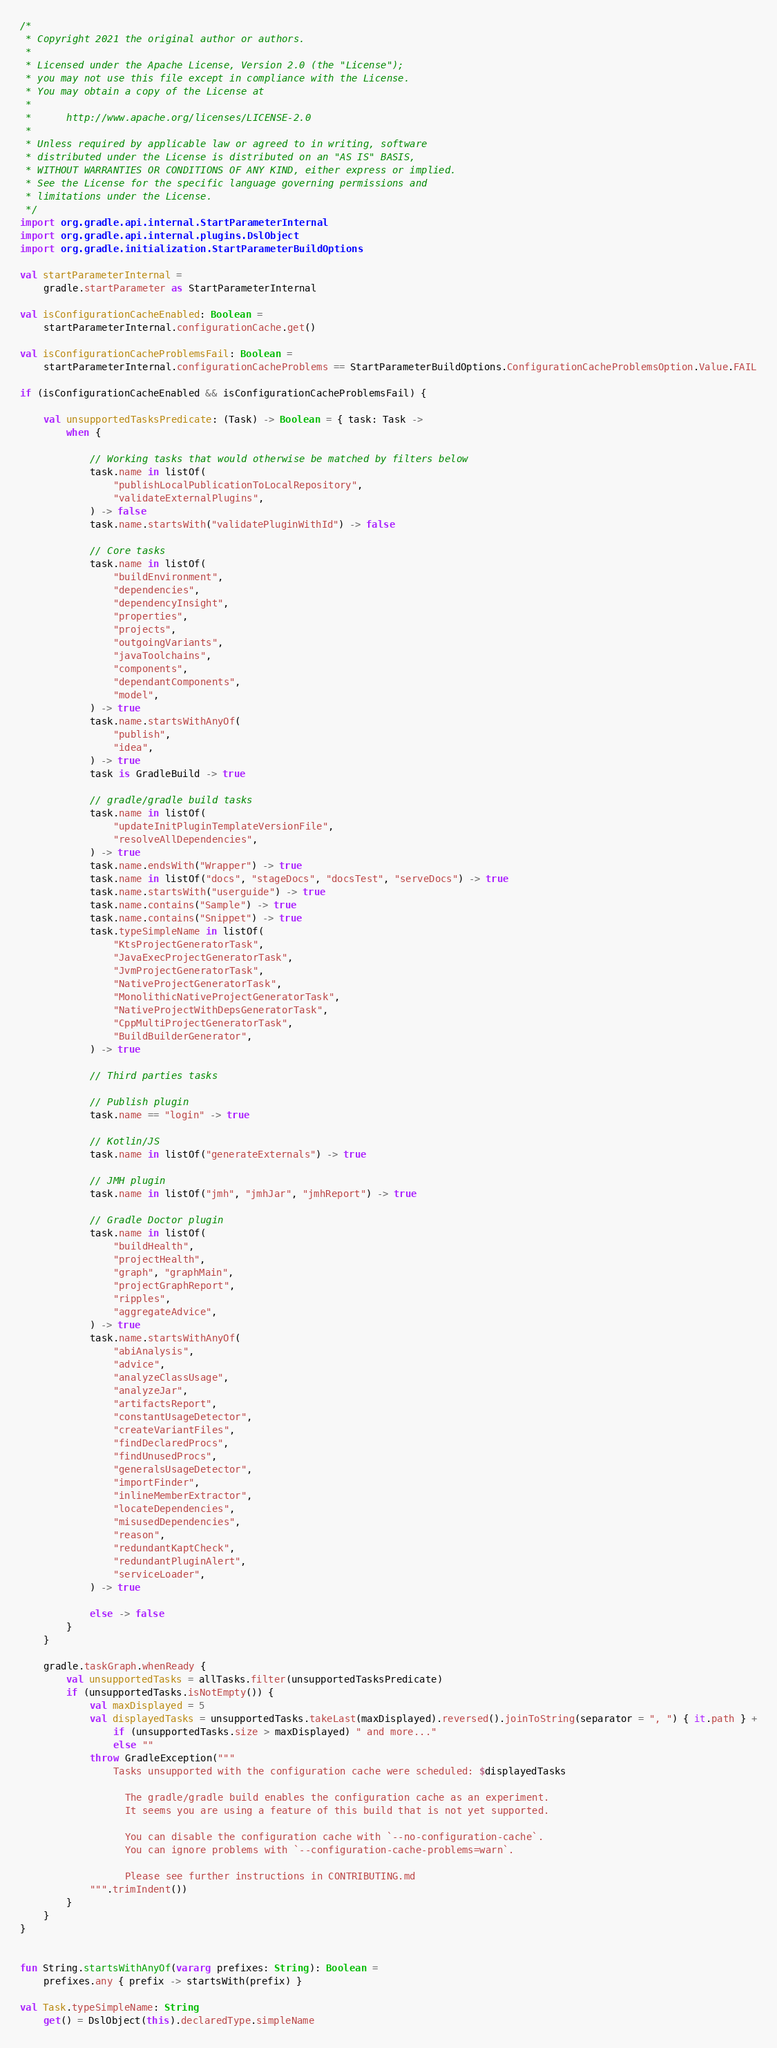<code> <loc_0><loc_0><loc_500><loc_500><_Kotlin_>/*
 * Copyright 2021 the original author or authors.
 *
 * Licensed under the Apache License, Version 2.0 (the "License");
 * you may not use this file except in compliance with the License.
 * You may obtain a copy of the License at
 *
 *      http://www.apache.org/licenses/LICENSE-2.0
 *
 * Unless required by applicable law or agreed to in writing, software
 * distributed under the License is distributed on an "AS IS" BASIS,
 * WITHOUT WARRANTIES OR CONDITIONS OF ANY KIND, either express or implied.
 * See the License for the specific language governing permissions and
 * limitations under the License.
 */
import org.gradle.api.internal.StartParameterInternal
import org.gradle.api.internal.plugins.DslObject
import org.gradle.initialization.StartParameterBuildOptions

val startParameterInternal =
    gradle.startParameter as StartParameterInternal

val isConfigurationCacheEnabled: Boolean =
    startParameterInternal.configurationCache.get()

val isConfigurationCacheProblemsFail: Boolean =
    startParameterInternal.configurationCacheProblems == StartParameterBuildOptions.ConfigurationCacheProblemsOption.Value.FAIL

if (isConfigurationCacheEnabled && isConfigurationCacheProblemsFail) {

    val unsupportedTasksPredicate: (Task) -> Boolean = { task: Task ->
        when {

            // Working tasks that would otherwise be matched by filters below
            task.name in listOf(
                "publishLocalPublicationToLocalRepository",
                "validateExternalPlugins",
            ) -> false
            task.name.startsWith("validatePluginWithId") -> false

            // Core tasks
            task.name in listOf(
                "buildEnvironment",
                "dependencies",
                "dependencyInsight",
                "properties",
                "projects",
                "outgoingVariants",
                "javaToolchains",
                "components",
                "dependantComponents",
                "model",
            ) -> true
            task.name.startsWithAnyOf(
                "publish",
                "idea",
            ) -> true
            task is GradleBuild -> true

            // gradle/gradle build tasks
            task.name in listOf(
                "updateInitPluginTemplateVersionFile",
                "resolveAllDependencies",
            ) -> true
            task.name.endsWith("Wrapper") -> true
            task.name in listOf("docs", "stageDocs", "docsTest", "serveDocs") -> true
            task.name.startsWith("userguide") -> true
            task.name.contains("Sample") -> true
            task.name.contains("Snippet") -> true
            task.typeSimpleName in listOf(
                "KtsProjectGeneratorTask",
                "JavaExecProjectGeneratorTask",
                "JvmProjectGeneratorTask",
                "NativeProjectGeneratorTask",
                "MonolithicNativeProjectGeneratorTask",
                "NativeProjectWithDepsGeneratorTask",
                "CppMultiProjectGeneratorTask",
                "BuildBuilderGenerator",
            ) -> true

            // Third parties tasks

            // Publish plugin
            task.name == "login" -> true

            // Kotlin/JS
            task.name in listOf("generateExternals") -> true

            // JMH plugin
            task.name in listOf("jmh", "jmhJar", "jmhReport") -> true

            // Gradle Doctor plugin
            task.name in listOf(
                "buildHealth",
                "projectHealth",
                "graph", "graphMain",
                "projectGraphReport",
                "ripples",
                "aggregateAdvice",
            ) -> true
            task.name.startsWithAnyOf(
                "abiAnalysis",
                "advice",
                "analyzeClassUsage",
                "analyzeJar",
                "artifactsReport",
                "constantUsageDetector",
                "createVariantFiles",
                "findDeclaredProcs",
                "findUnusedProcs",
                "generalsUsageDetector",
                "importFinder",
                "inlineMemberExtractor",
                "locateDependencies",
                "misusedDependencies",
                "reason",
                "redundantKaptCheck",
                "redundantPluginAlert",
                "serviceLoader",
            ) -> true

            else -> false
        }
    }

    gradle.taskGraph.whenReady {
        val unsupportedTasks = allTasks.filter(unsupportedTasksPredicate)
        if (unsupportedTasks.isNotEmpty()) {
            val maxDisplayed = 5
            val displayedTasks = unsupportedTasks.takeLast(maxDisplayed).reversed().joinToString(separator = ", ") { it.path } +
                if (unsupportedTasks.size > maxDisplayed) " and more..."
                else ""
            throw GradleException("""
                Tasks unsupported with the configuration cache were scheduled: $displayedTasks

                  The gradle/gradle build enables the configuration cache as an experiment.
                  It seems you are using a feature of this build that is not yet supported.

                  You can disable the configuration cache with `--no-configuration-cache`.
                  You can ignore problems with `--configuration-cache-problems=warn`.

                  Please see further instructions in CONTRIBUTING.md
            """.trimIndent())
        }
    }
}


fun String.startsWithAnyOf(vararg prefixes: String): Boolean =
    prefixes.any { prefix -> startsWith(prefix) }

val Task.typeSimpleName: String
    get() = DslObject(this).declaredType.simpleName
</code> 